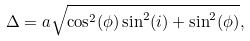<formula> <loc_0><loc_0><loc_500><loc_500>\Delta = a \sqrt { \cos ^ { 2 } ( \phi ) \sin ^ { 2 } ( i ) + \sin ^ { 2 } ( \phi ) } ,</formula> 